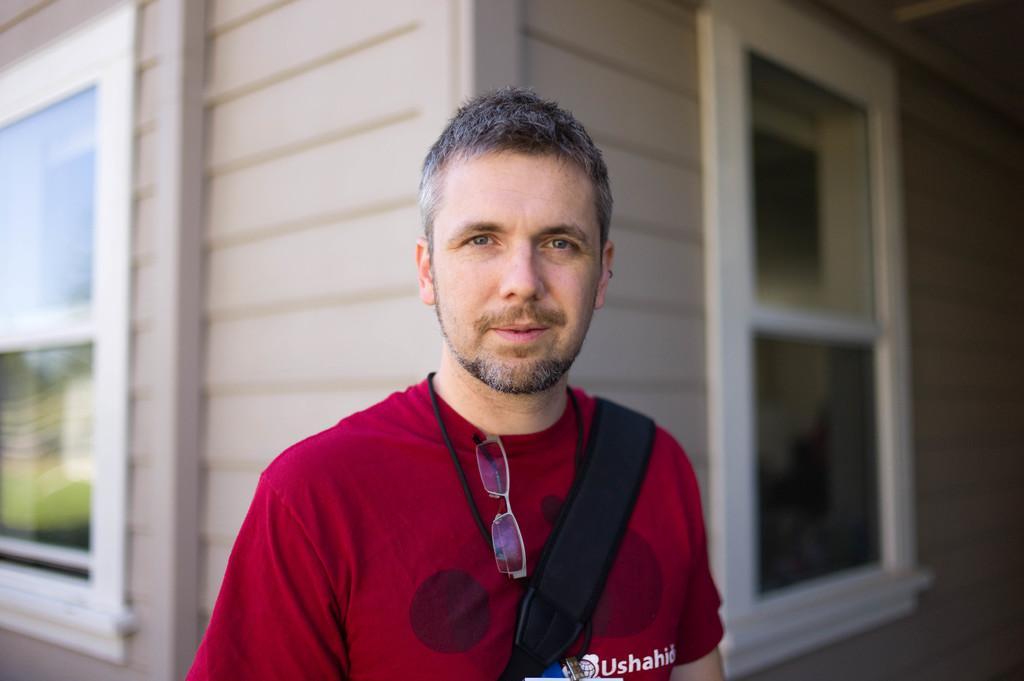Please provide a concise description of this image. In this picture we can see a man standing in front of a place with windows and looking at someone. 